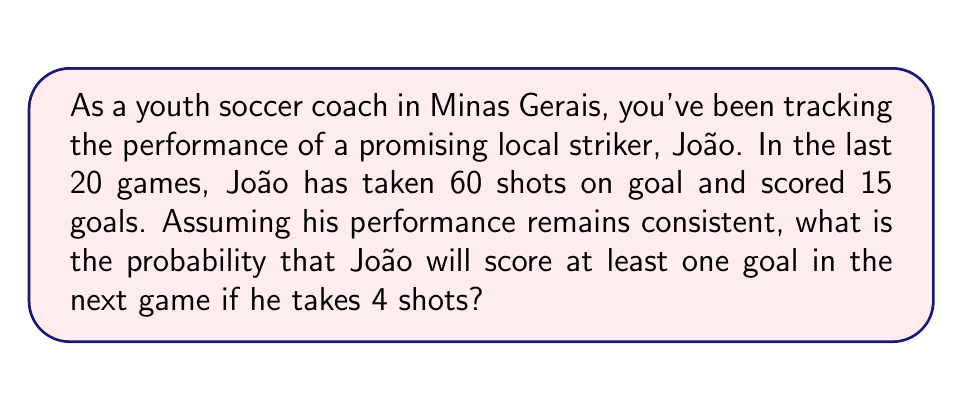Solve this math problem. Let's approach this step-by-step using probability theory:

1) First, we need to calculate the probability of João scoring on a single shot. This can be estimated from his historical data:

   $P(\text{scoring on one shot}) = \frac{\text{goals scored}}{\text{total shots}} = \frac{15}{60} = 0.25$ or 25%

2) Now, we need to find the probability of João scoring at least one goal in 4 shots. It's easier to calculate the opposite event - the probability of him not scoring on any of the 4 shots, and then subtract this from 1.

3) The probability of not scoring on a single shot is:

   $P(\text{not scoring on one shot}) = 1 - P(\text{scoring on one shot}) = 1 - 0.25 = 0.75$ or 75%

4) For João to not score on any of the 4 shots, he needs to miss all 4 independently. We can calculate this using the multiplication rule of probability:

   $P(\text{not scoring on 4 shots}) = 0.75 * 0.75 * 0.75 * 0.75 = 0.75^4 \approx 0.3164$

5) Therefore, the probability of scoring at least one goal in 4 shots is:

   $P(\text{scoring at least one goal}) = 1 - P(\text{not scoring on 4 shots}) = 1 - 0.3164 = 0.6836$

Thus, there is approximately a 68.36% chance that João will score at least one goal in the next game if he takes 4 shots.
Answer: $0.6836$ or $68.36\%$ 